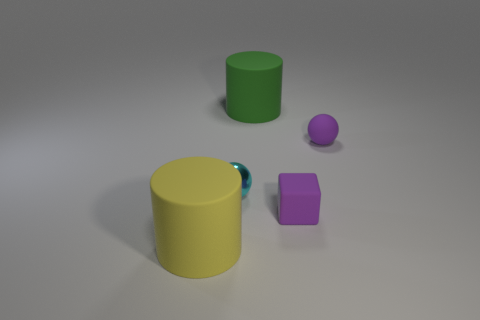Can you describe the lighting in this scene? The lighting in the image appears to be soft and diffused, with gentle shadows cast by the objects indicating an overhead light source. There's no harsh contrast, suggesting that the lighting is even, possibly emulating an overcast day or studio lighting with a diffuser. 